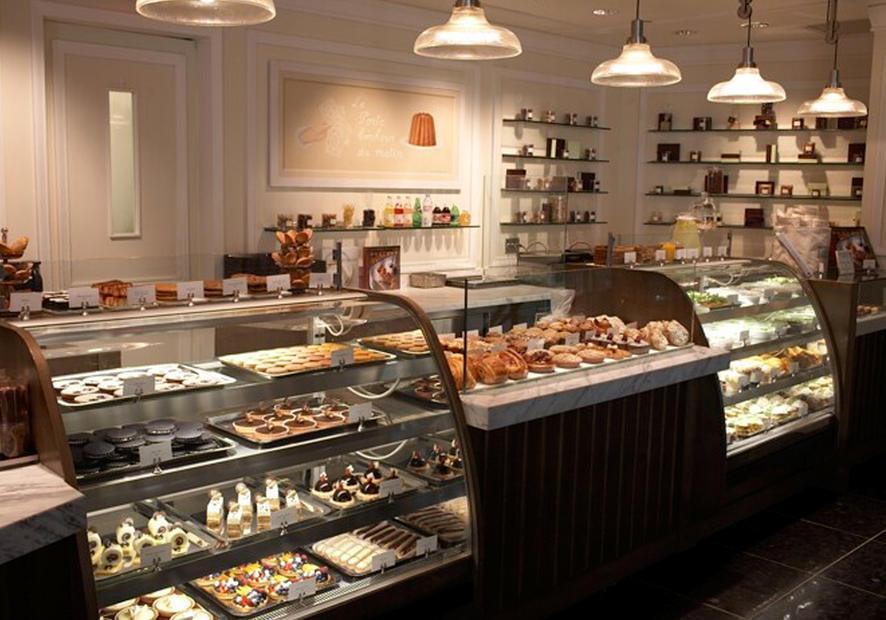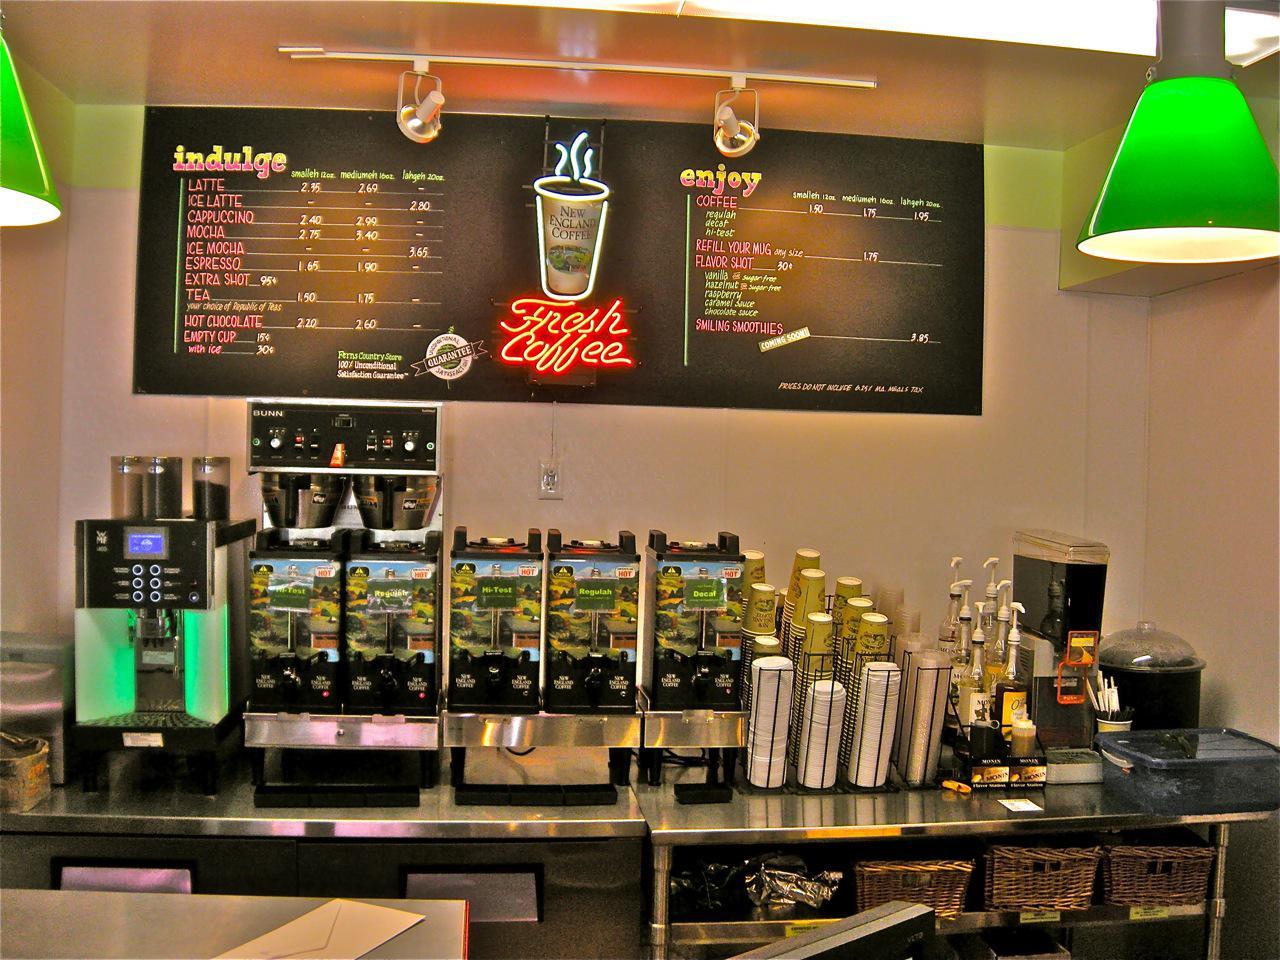The first image is the image on the left, the second image is the image on the right. For the images shown, is this caption "In at least one image there are two bright lights focused on a coffee chalkboard." true? Answer yes or no. Yes. The first image is the image on the left, the second image is the image on the right. Examine the images to the left and right. Is the description "At least one person is standing at a counter and at least one person is sitting at a table with wood chairs around it in one image." accurate? Answer yes or no. No. 